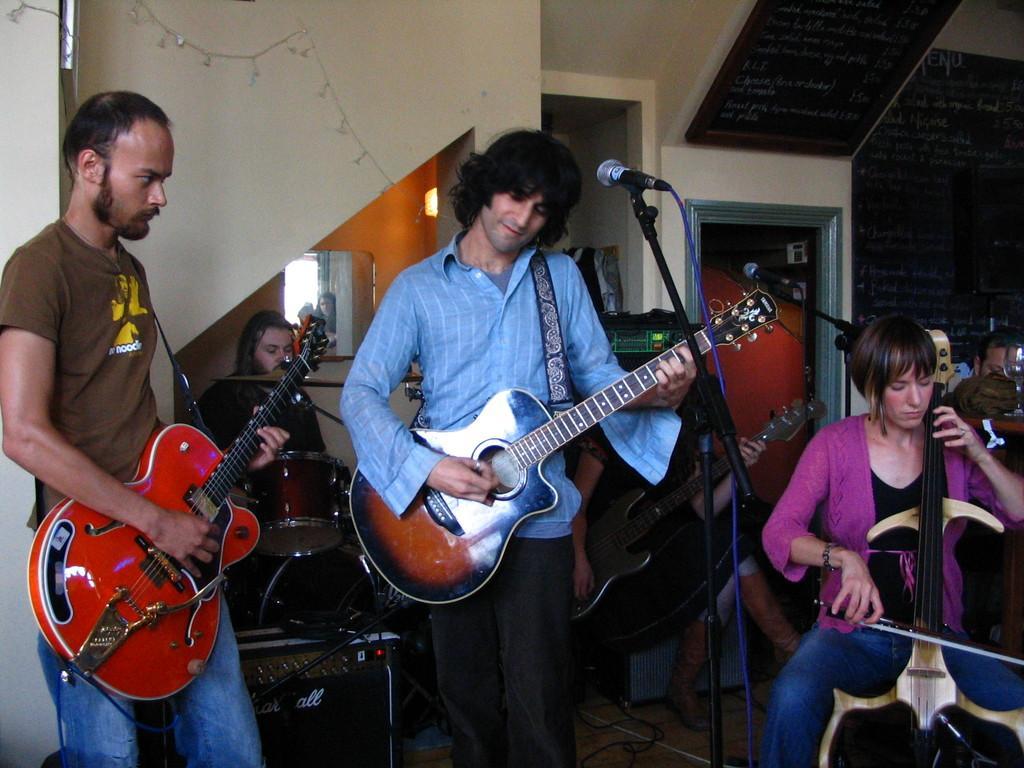How would you summarize this image in a sentence or two? The person wearing brown,blue and black are playing guitar and the person in the right corner is playing violin and the person in the background is playing drums. 